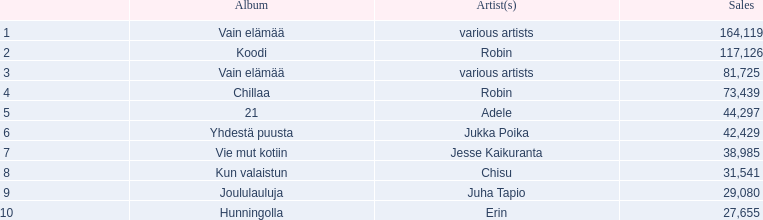Could you help me parse every detail presented in this table? {'header': ['', 'Album', 'Artist(s)', 'Sales'], 'rows': [['1', 'Vain elämää', 'various artists', '164,119'], ['2', 'Koodi', 'Robin', '117,126'], ['3', 'Vain elämää', 'various artists', '81,725'], ['4', 'Chillaa', 'Robin', '73,439'], ['5', '21', 'Adele', '44,297'], ['6', 'Yhdestä puusta', 'Jukka Poika', '42,429'], ['7', 'Vie mut kotiin', 'Jesse Kaikuranta', '38,985'], ['8', 'Kun valaistun', 'Chisu', '31,541'], ['9', 'Joululauluja', 'Juha Tapio', '29,080'], ['10', 'Hunningolla', 'Erin', '27,655']]} What sales does adele have? 44,297. What sales does chisu have? 31,541. Which of these numbers are higher? 44,297. Who has this number of sales? Adele. 